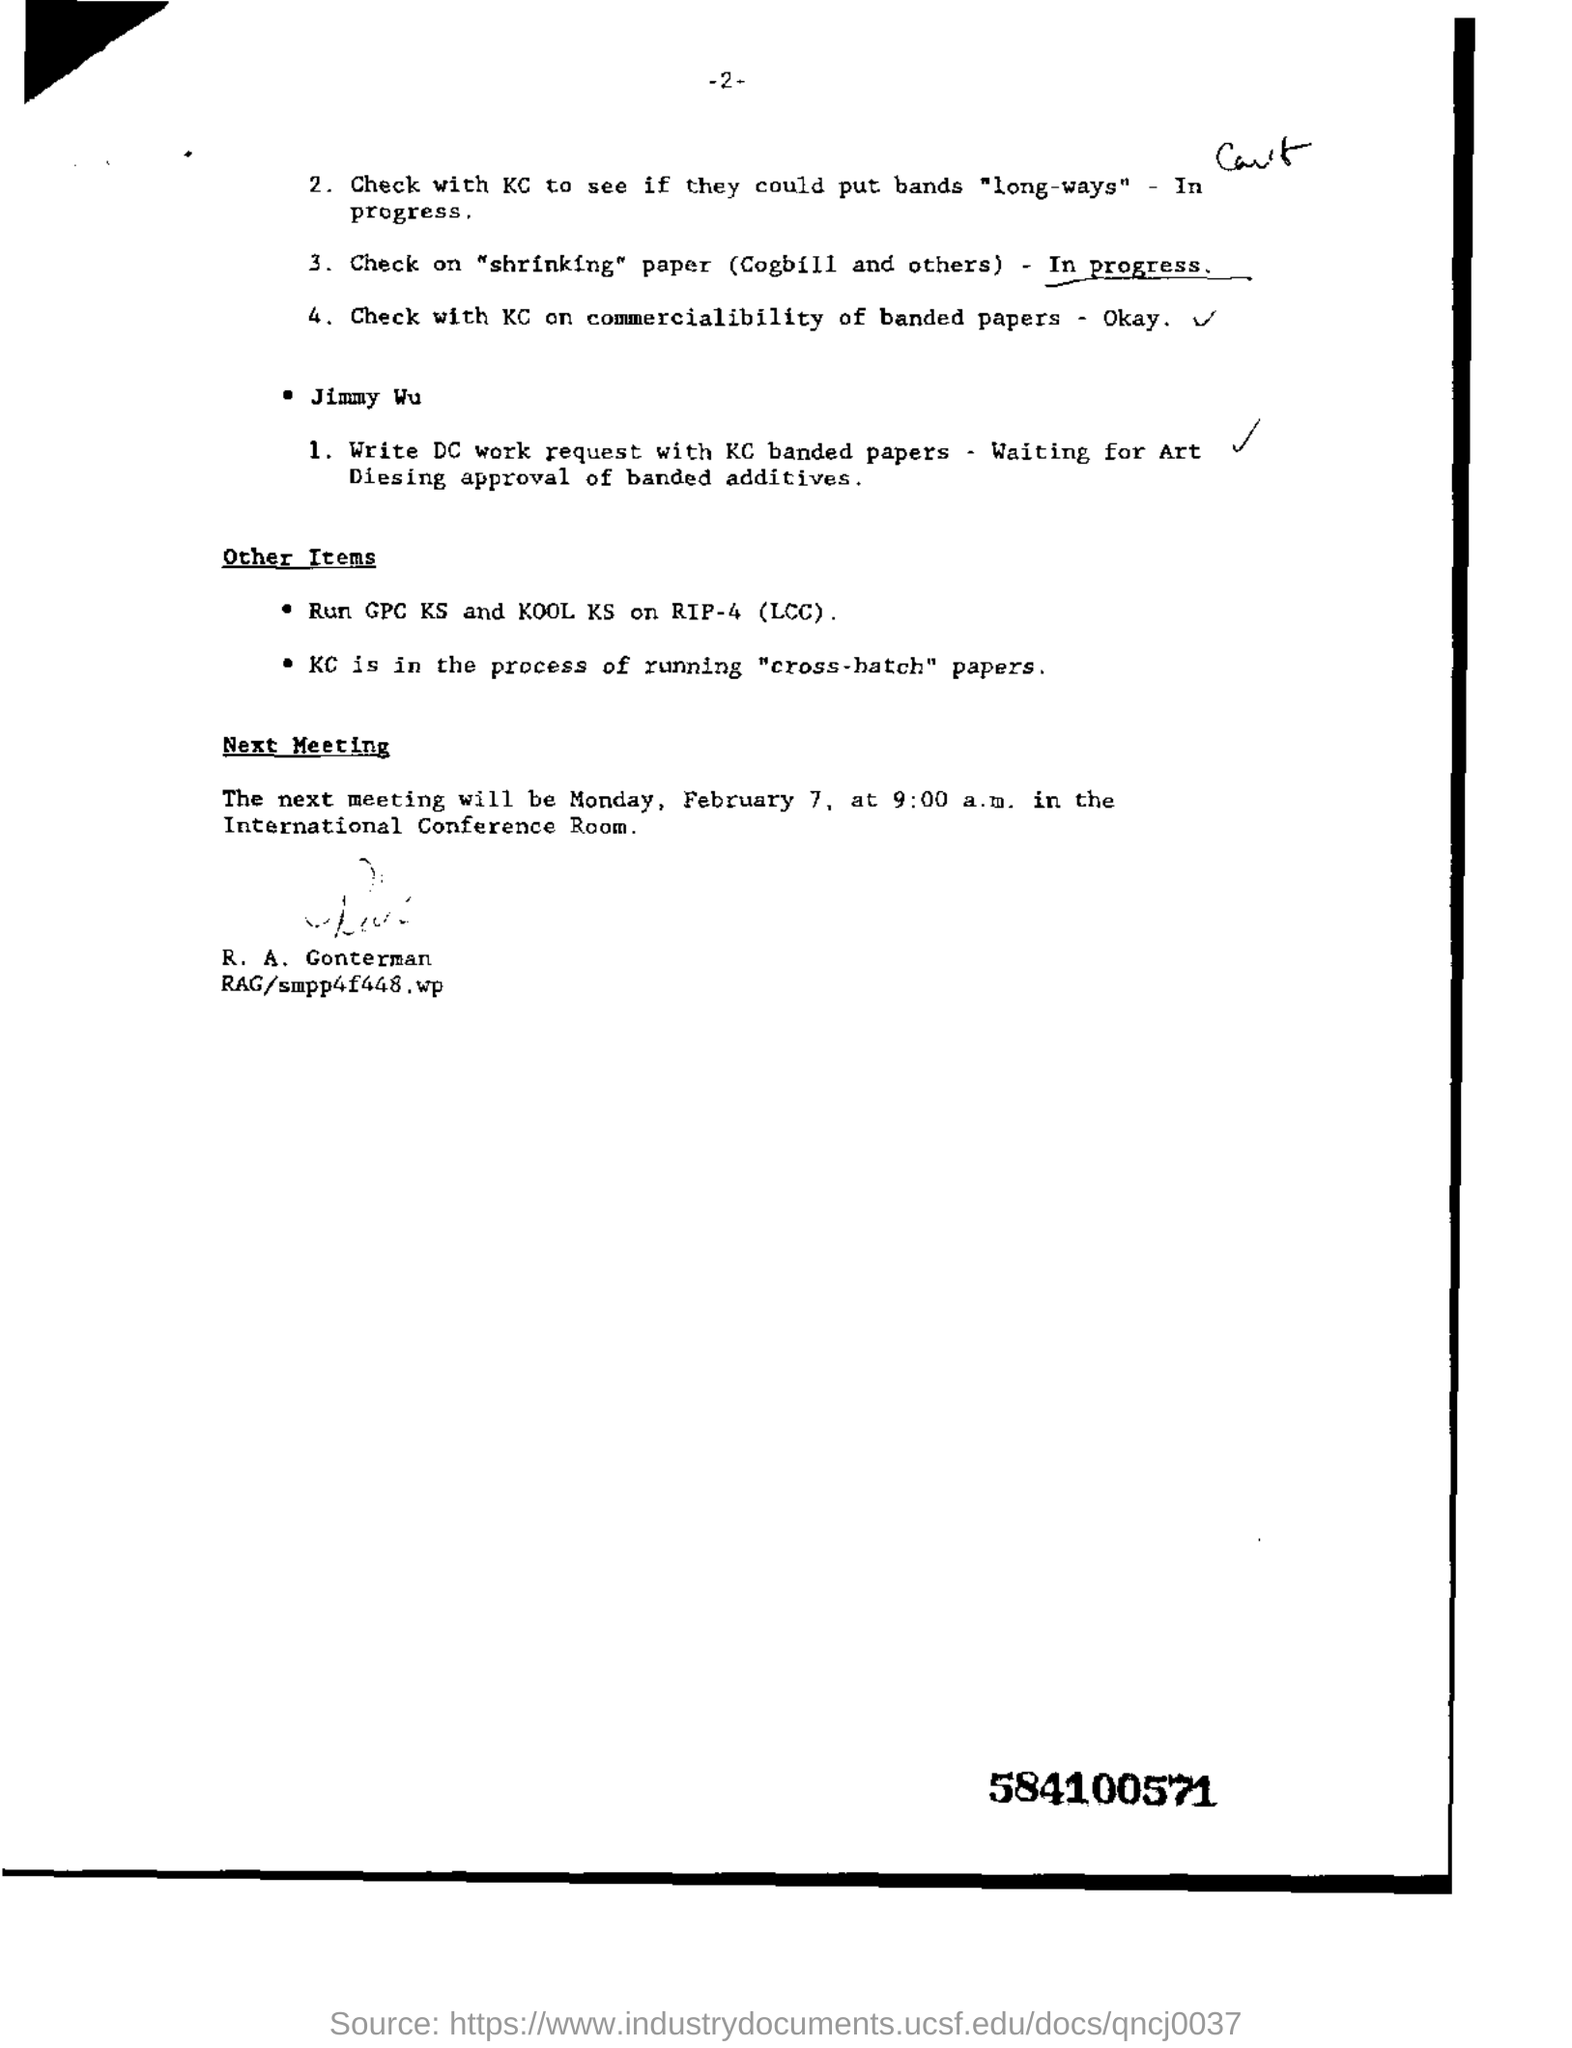When will be the next meeting?
Offer a very short reply. Monday, February 7, at 9:00 a.m. In which room the meeting will be held?
Ensure brevity in your answer.  The international conference room. Who has signed the document?
Offer a terse response. R. A. Gonterman. With what should the dc work request be written?
Provide a short and direct response. KC banded papers. What is the code on the bottom right corner?
Your answer should be compact. 584100571. 